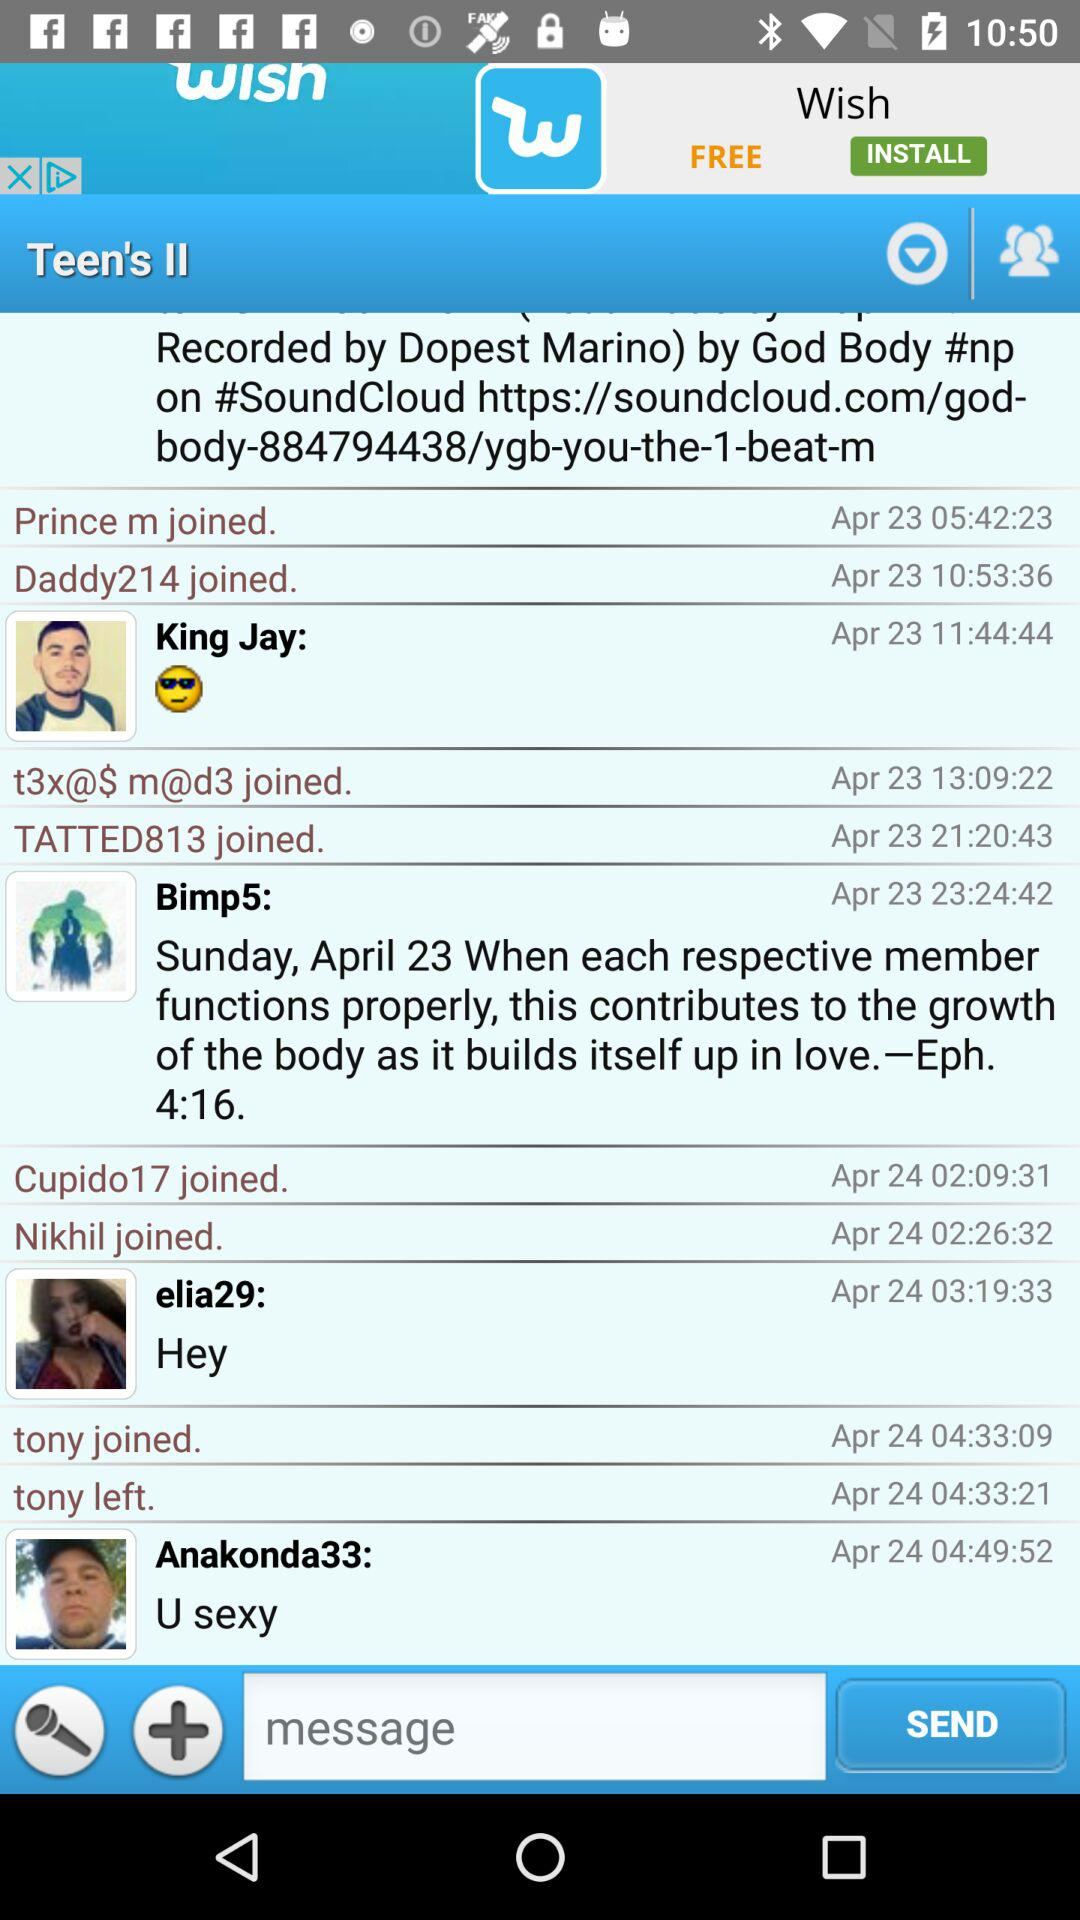At what date did Elia29 comment? Elia29 commented on April 24. 